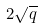<formula> <loc_0><loc_0><loc_500><loc_500>2 \sqrt { q }</formula> 